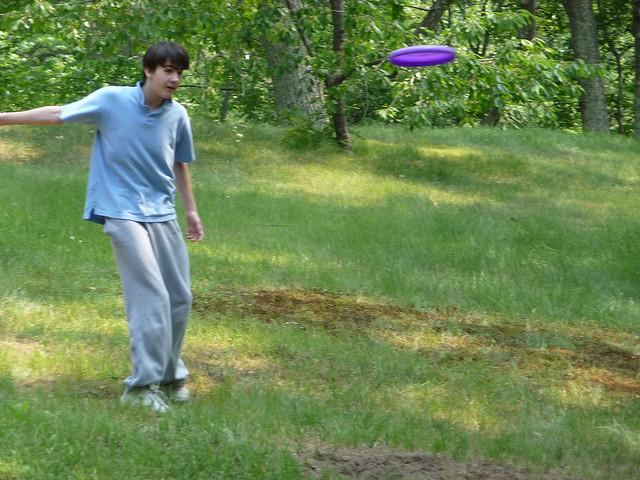What is the man playing?
Keep it brief. Frisbee. Is the frisbee about to hit the man?
Write a very short answer. No. Where is the Frisbee?
Write a very short answer. Air. Does he wear glasses?
Concise answer only. No. 